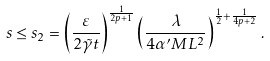<formula> <loc_0><loc_0><loc_500><loc_500>s \leq s _ { 2 } = \left ( \frac { \varepsilon } { 2 \tilde { \gamma } t } \right ) ^ { \frac { 1 } { 2 p + 1 } } \left ( \frac { \lambda } { 4 \alpha ^ { \prime } M L ^ { 2 } } \right ) ^ { \frac { 1 } { 2 } + \frac { 1 } { 4 p + 2 } } .</formula> 